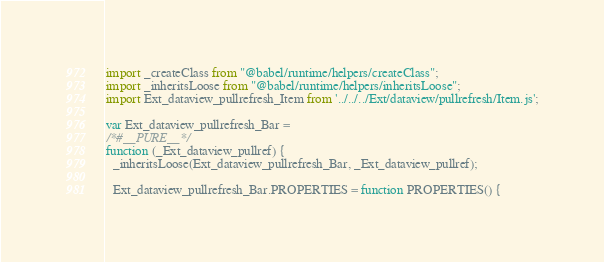Convert code to text. <code><loc_0><loc_0><loc_500><loc_500><_JavaScript_>import _createClass from "@babel/runtime/helpers/createClass";
import _inheritsLoose from "@babel/runtime/helpers/inheritsLoose";
import Ext_dataview_pullrefresh_Item from '../../../Ext/dataview/pullrefresh/Item.js';

var Ext_dataview_pullrefresh_Bar =
/*#__PURE__*/
function (_Ext_dataview_pullref) {
  _inheritsLoose(Ext_dataview_pullrefresh_Bar, _Ext_dataview_pullref);

  Ext_dataview_pullrefresh_Bar.PROPERTIES = function PROPERTIES() {</code> 